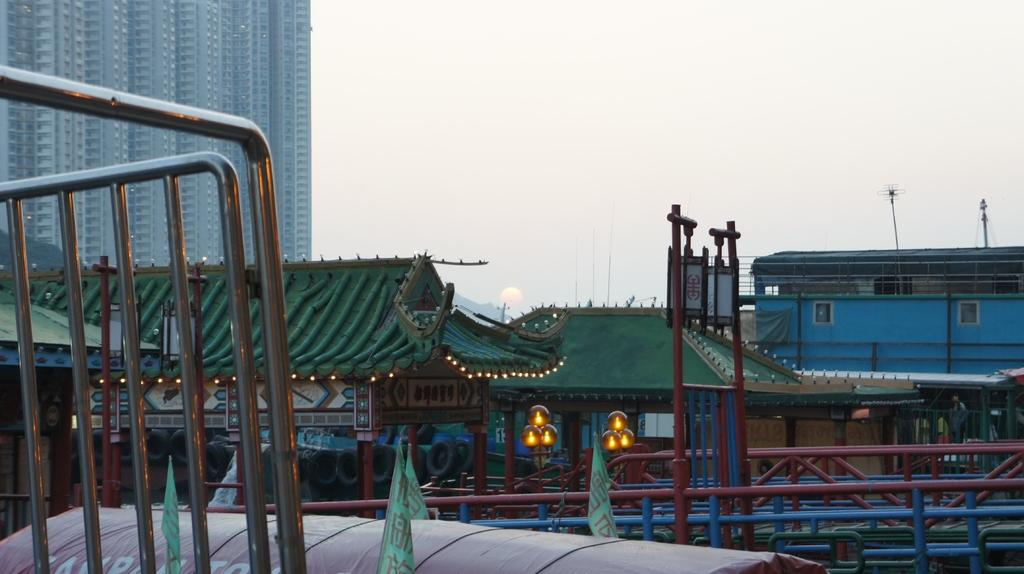What structures with lights can be seen in the image? There are sheds with lights in the image. What other objects are present in the image? There are poles, iron rods, flags, and tyres visible in the image. Where are the buildings located in the image? The buildings are on the left side of the image. What can be seen in the background of the image? The sky is visible in the background of the image. Can you tell me which direction your uncle is walking in the image? There is no person, including an uncle, present in the image, so it is not possible to determine the direction in which they might be walking. 